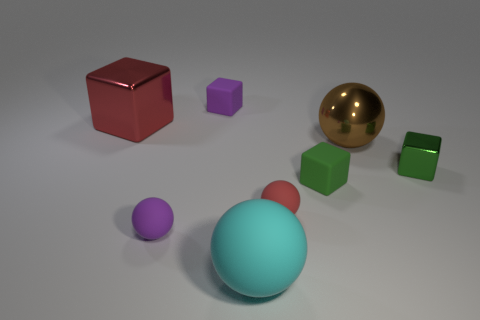If these objects were part of a game, what kind of game could it be? If these objects were part of a game, it might be a physical puzzle game where players must arrange the objects according to specific rules related to size, color, or material. Alternatively, it could be an educational game for children to learn about geometry and color recognition. 